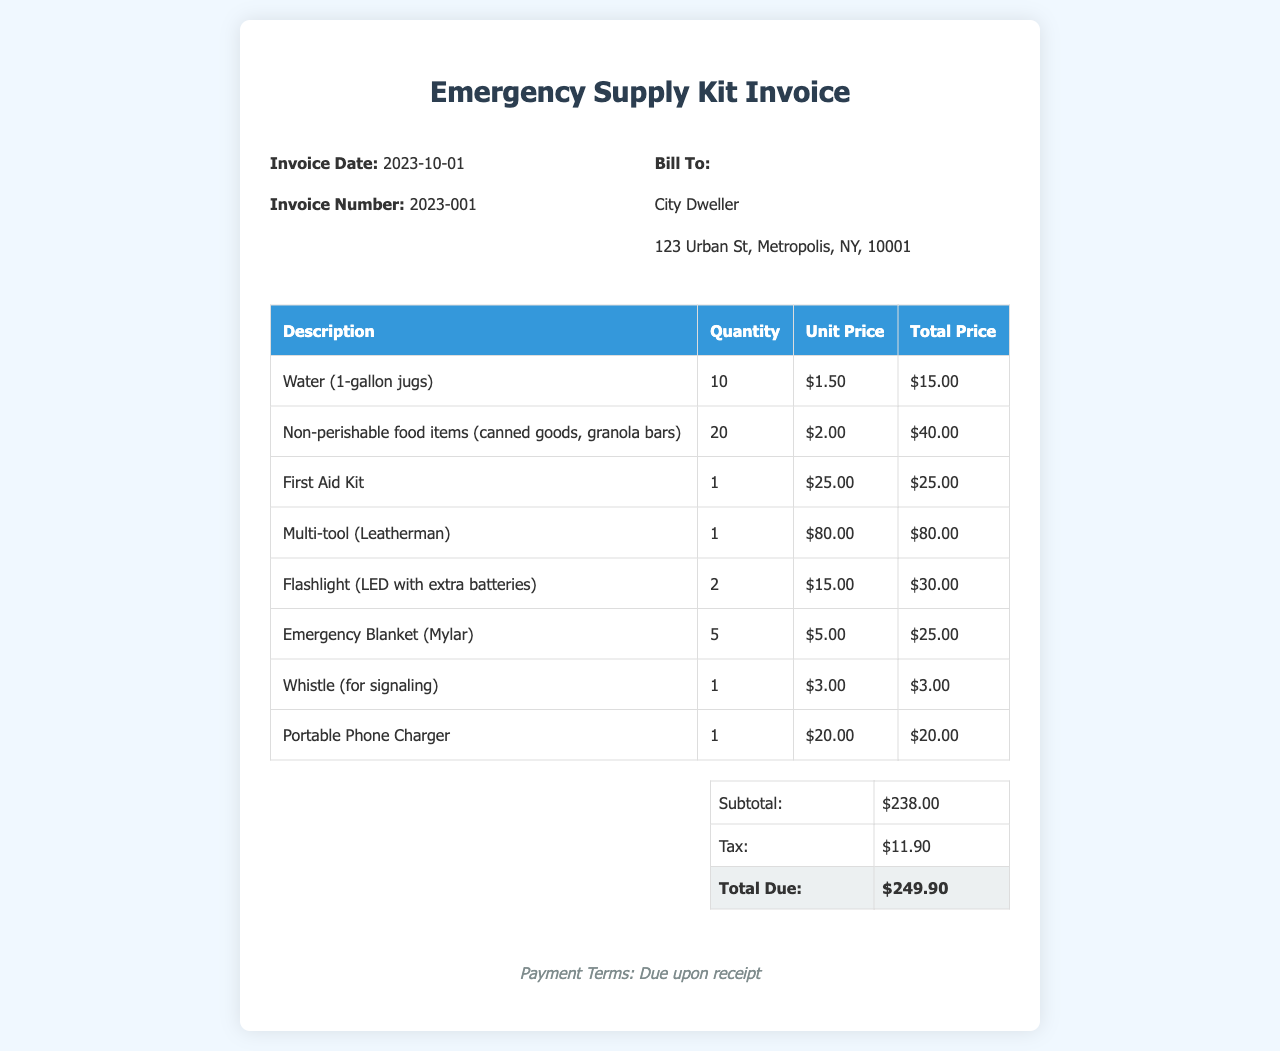What is the invoice date? The invoice date is stated in the invoice header section, which is 2023-10-01.
Answer: 2023-10-01 What is the total due amount? The total due amount is summarized in the total section of the invoice, which states $249.90.
Answer: $249.90 How many gallons of water were purchased? The quantity of water purchased is listed in the table, which shows 10 jugs.
Answer: 10 What is the unit price of the First Aid Kit? The unit price of the First Aid Kit is mentioned in the invoice table, which is $25.00.
Answer: $25.00 What are the payment terms? The payment terms are mentioned at the bottom of the invoice, which states "Due upon receipt."
Answer: Due upon receipt What is the subtotal before tax? The subtotal is indicated in the total table above tax, which is $238.00.
Answer: $238.00 How many non-perishable food items were included? The quantity of non-perishable food items is specified in the table, which is 20.
Answer: 20 What type of flashlight was included in the supplies? The type of flashlight is described in the invoice table, which is an "LED with extra batteries."
Answer: LED with extra batteries What is the quantity of emergency blankets purchased? The quantity of emergency blankets is listed in the invoice table, which shows 5.
Answer: 5 